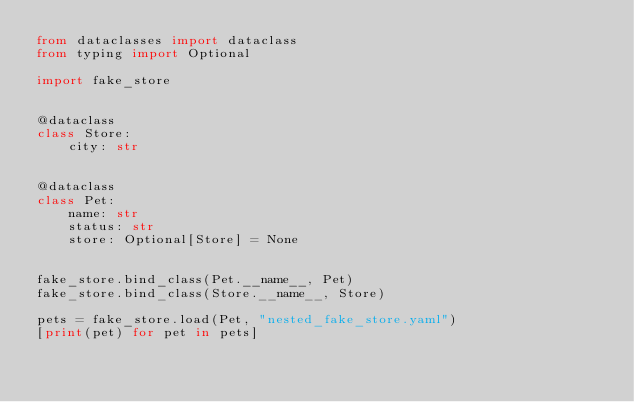<code> <loc_0><loc_0><loc_500><loc_500><_Python_>from dataclasses import dataclass
from typing import Optional

import fake_store


@dataclass
class Store:
    city: str


@dataclass
class Pet:
    name: str
    status: str
    store: Optional[Store] = None


fake_store.bind_class(Pet.__name__, Pet)
fake_store.bind_class(Store.__name__, Store)

pets = fake_store.load(Pet, "nested_fake_store.yaml")
[print(pet) for pet in pets]


</code> 